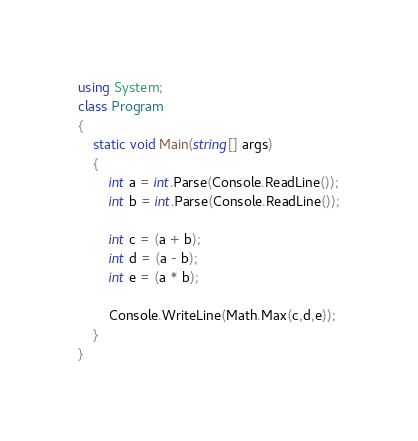Convert code to text. <code><loc_0><loc_0><loc_500><loc_500><_C#_>using System;
class Program
{
    static void Main(string[] args)
    {
        int a = int.Parse(Console.ReadLine());
        int b = int.Parse(Console.ReadLine());

        int c = (a + b);
        int d = (a - b);
        int e = (a * b);

        Console.WriteLine(Math.Max(c,d,e));
    }
}</code> 